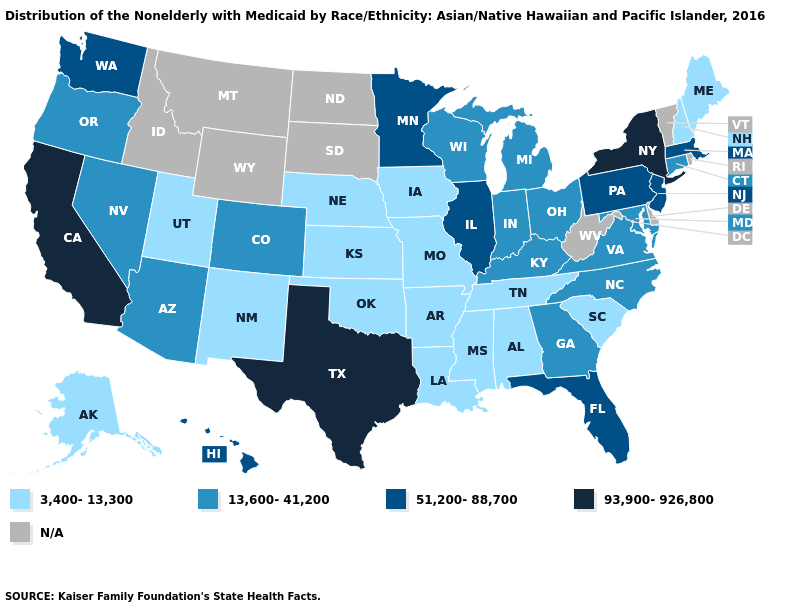Name the states that have a value in the range 93,900-926,800?
Quick response, please. California, New York, Texas. Among the states that border Oklahoma , does Kansas have the highest value?
Answer briefly. No. Does the map have missing data?
Short answer required. Yes. What is the highest value in the USA?
Be succinct. 93,900-926,800. What is the value of Virginia?
Quick response, please. 13,600-41,200. What is the highest value in the USA?
Short answer required. 93,900-926,800. Does the map have missing data?
Concise answer only. Yes. Among the states that border Minnesota , does Wisconsin have the lowest value?
Concise answer only. No. What is the value of Delaware?
Quick response, please. N/A. Among the states that border Illinois , does Iowa have the highest value?
Concise answer only. No. Does South Carolina have the lowest value in the USA?
Concise answer only. Yes. Does Maine have the lowest value in the Northeast?
Keep it brief. Yes. Name the states that have a value in the range 3,400-13,300?
Quick response, please. Alabama, Alaska, Arkansas, Iowa, Kansas, Louisiana, Maine, Mississippi, Missouri, Nebraska, New Hampshire, New Mexico, Oklahoma, South Carolina, Tennessee, Utah. 